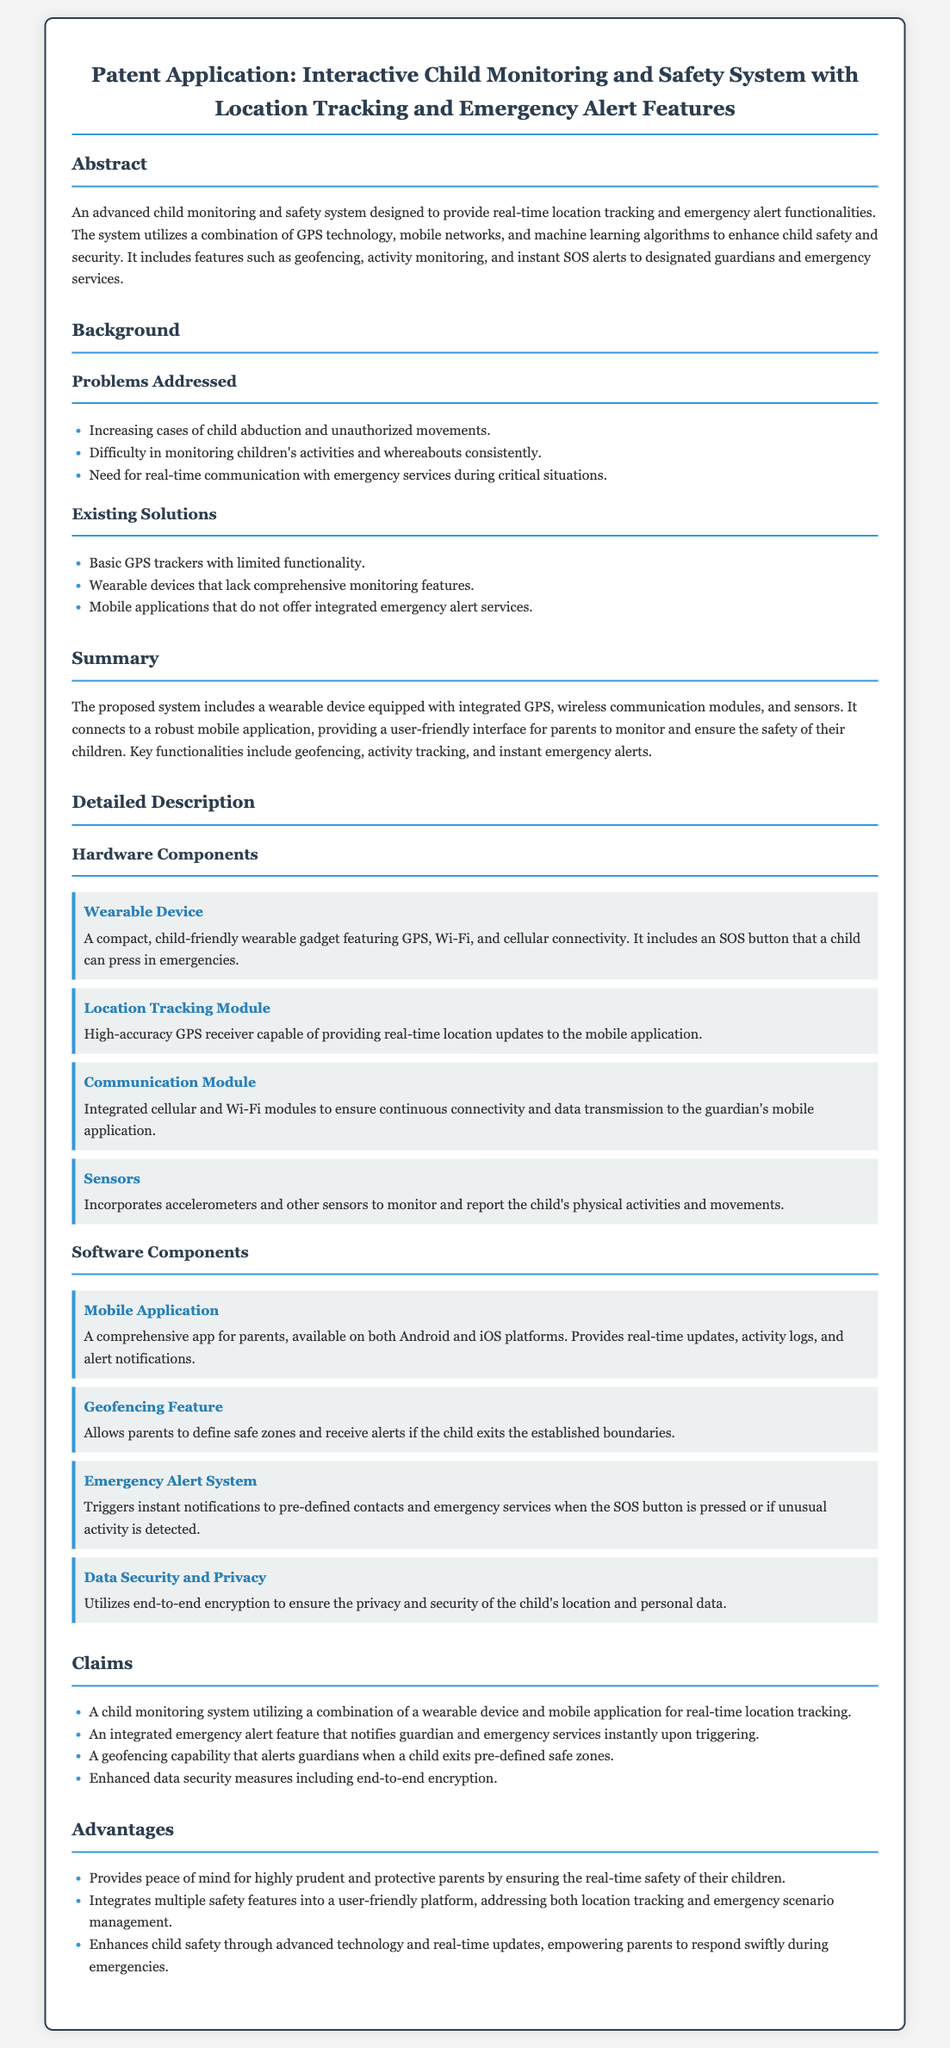What is the purpose of the system? The system is designed to provide real-time location tracking and emergency alert functionalities to enhance child safety and security.
Answer: real-time location tracking and emergency alert functionalities What is the key feature that allows parents to define safe zones? The feature enables parents to set boundaries and receive alerts when a child exits those areas.
Answer: Geofencing What technology is primarily used for tracking? The system utilizes Global Positioning System technology for location tracking.
Answer: GPS What type of communication modules are included in the device? The device has integrated cellular and Wi-Fi communication modules to ensure connectivity.
Answer: Cellular and Wi-Fi How many claims are listed in the patent application? The document outlines four specific claims related to the system's functionality.
Answer: Four What problem does the system address regarding child monitoring? It addresses the difficulty in consistently monitoring children's activities and whereabouts.
Answer: Difficulty in monitoring children's activities and whereabouts What emergency feature is triggered by pressing a specific button? The SOS button, when pressed, activates the emergency alert system.
Answer: SOS button What ensures the security of the child's data in the system? The system employs end-to-end encryption to maintain privacy and security.
Answer: end-to-end encryption What type of application is developed for the parents? A comprehensive mobile application is designed for parents on both Android and iOS platforms.
Answer: Mobile Application 